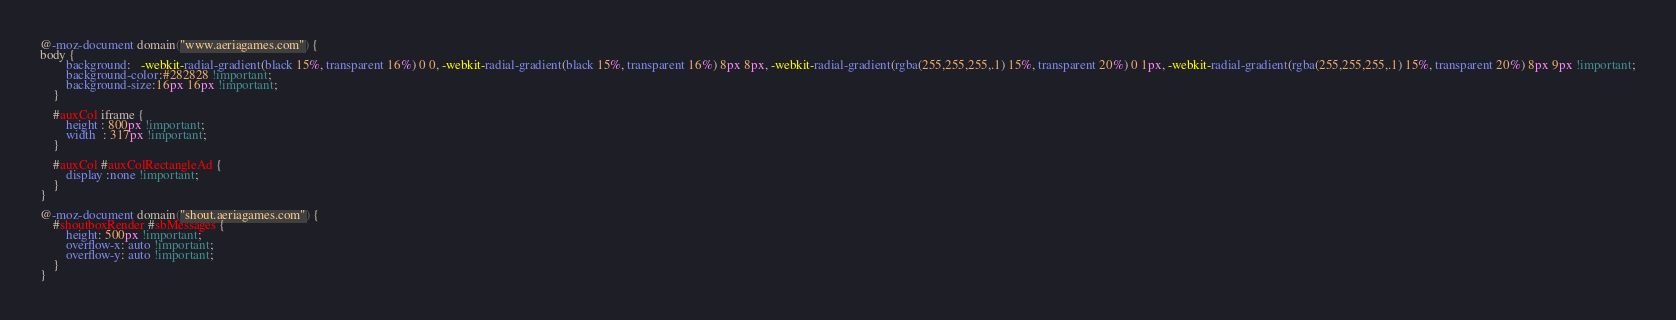Convert code to text. <code><loc_0><loc_0><loc_500><loc_500><_CSS_>@-moz-document domain("www.aeriagames.com") {
body {
        background:   -webkit-radial-gradient(black 15%, transparent 16%) 0 0, -webkit-radial-gradient(black 15%, transparent 16%) 8px 8px, -webkit-radial-gradient(rgba(255,255,255,.1) 15%, transparent 20%) 0 1px, -webkit-radial-gradient(rgba(255,255,255,.1) 15%, transparent 20%) 8px 9px !important;
        background-color:#282828 !important;
        background-size:16px 16px !important;
    }

    #auxCol iframe {
        height : 800px !important;
        width  : 317px !important;
    }

    #auxCol #auxColRectangleAd {
        display :none !important;
    }
}

@-moz-document domain("shout.aeriagames.com") {
    #shoutboxRender #sbMessages {
        height: 500px !important;
        overflow-x: auto !important;
        overflow-y: auto !important;
    }
}</code> 